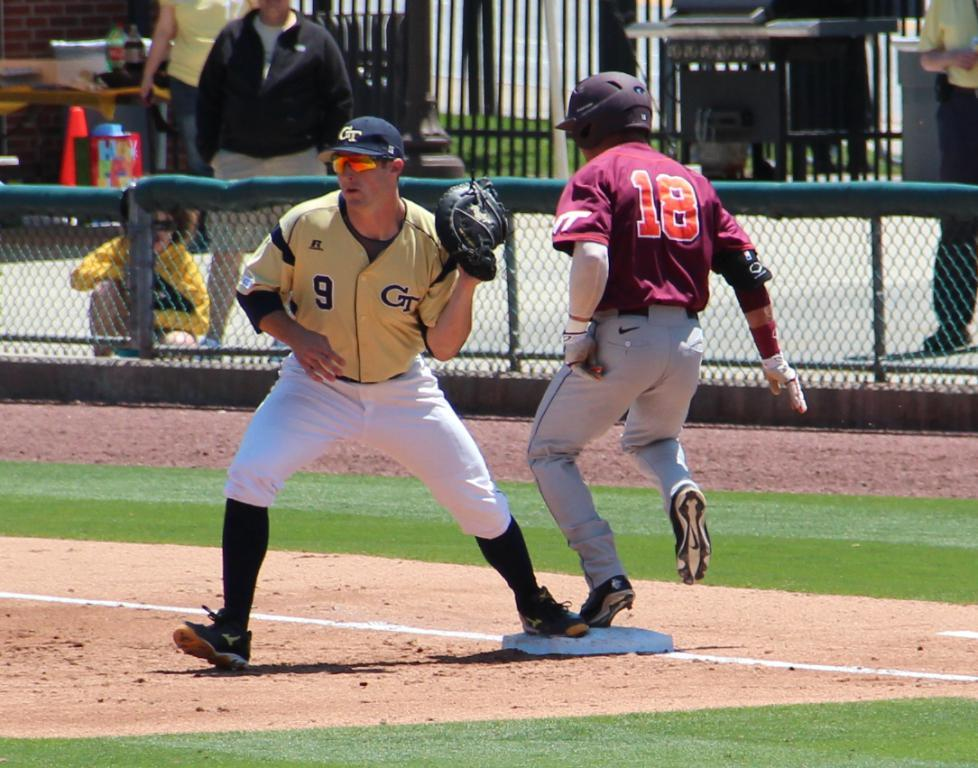Provide a one-sentence caption for the provided image. virginia tech player number 18 running to the base that georgia tech player number 9 is standing at. 